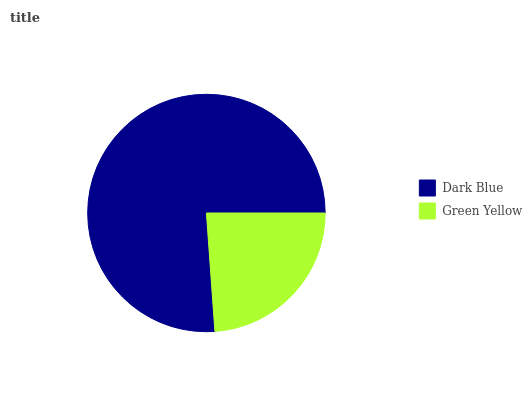Is Green Yellow the minimum?
Answer yes or no. Yes. Is Dark Blue the maximum?
Answer yes or no. Yes. Is Green Yellow the maximum?
Answer yes or no. No. Is Dark Blue greater than Green Yellow?
Answer yes or no. Yes. Is Green Yellow less than Dark Blue?
Answer yes or no. Yes. Is Green Yellow greater than Dark Blue?
Answer yes or no. No. Is Dark Blue less than Green Yellow?
Answer yes or no. No. Is Dark Blue the high median?
Answer yes or no. Yes. Is Green Yellow the low median?
Answer yes or no. Yes. Is Green Yellow the high median?
Answer yes or no. No. Is Dark Blue the low median?
Answer yes or no. No. 